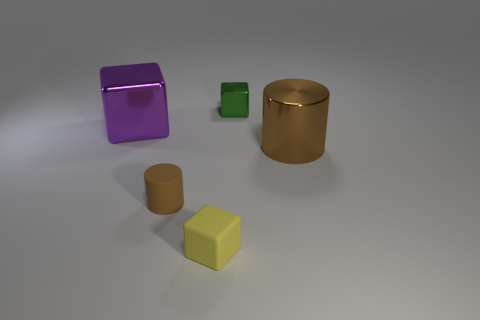Is the tiny rubber cylinder the same color as the big cylinder?
Your answer should be compact. Yes. What size is the other matte cylinder that is the same color as the big cylinder?
Provide a succinct answer. Small. There is a brown cylinder that is right of the brown cylinder that is on the left side of the small green cube; what is it made of?
Offer a very short reply. Metal. Are there any large brown metal objects behind the brown metallic object?
Offer a very short reply. No. Is the number of tiny metal blocks that are left of the tiny brown rubber cylinder greater than the number of big shiny cubes?
Your answer should be compact. No. Are there any big cubes of the same color as the metal cylinder?
Ensure brevity in your answer.  No. There is a metal object that is the same size as the brown rubber cylinder; what color is it?
Keep it short and to the point. Green. There is a large metallic object on the right side of the tiny metal thing; is there a thing in front of it?
Give a very brief answer. Yes. What material is the block left of the small matte block?
Ensure brevity in your answer.  Metal. Is the object left of the rubber cylinder made of the same material as the big object on the right side of the yellow block?
Give a very brief answer. Yes. 